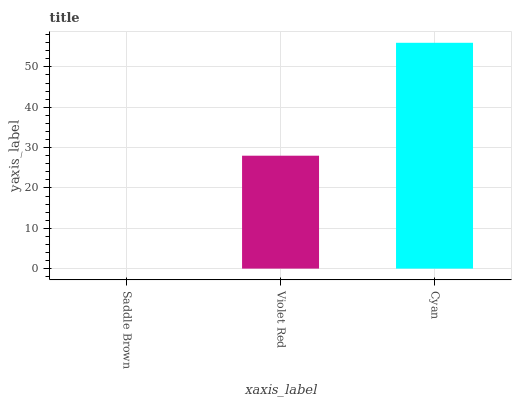Is Saddle Brown the minimum?
Answer yes or no. Yes. Is Cyan the maximum?
Answer yes or no. Yes. Is Violet Red the minimum?
Answer yes or no. No. Is Violet Red the maximum?
Answer yes or no. No. Is Violet Red greater than Saddle Brown?
Answer yes or no. Yes. Is Saddle Brown less than Violet Red?
Answer yes or no. Yes. Is Saddle Brown greater than Violet Red?
Answer yes or no. No. Is Violet Red less than Saddle Brown?
Answer yes or no. No. Is Violet Red the high median?
Answer yes or no. Yes. Is Violet Red the low median?
Answer yes or no. Yes. Is Saddle Brown the high median?
Answer yes or no. No. Is Cyan the low median?
Answer yes or no. No. 